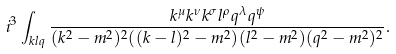Convert formula to latex. <formula><loc_0><loc_0><loc_500><loc_500>i ^ { 3 } \int _ { k l q } \frac { k ^ { \mu } k ^ { \nu } k ^ { \sigma } l ^ { \rho } q ^ { \lambda } q ^ { \psi } } { ( k ^ { 2 } - m ^ { 2 } ) ^ { 2 } ( ( k - l ) ^ { 2 } - m ^ { 2 } ) ( l ^ { 2 } - m ^ { 2 } ) ( q ^ { 2 } - m ^ { 2 } ) ^ { 2 } } .</formula> 